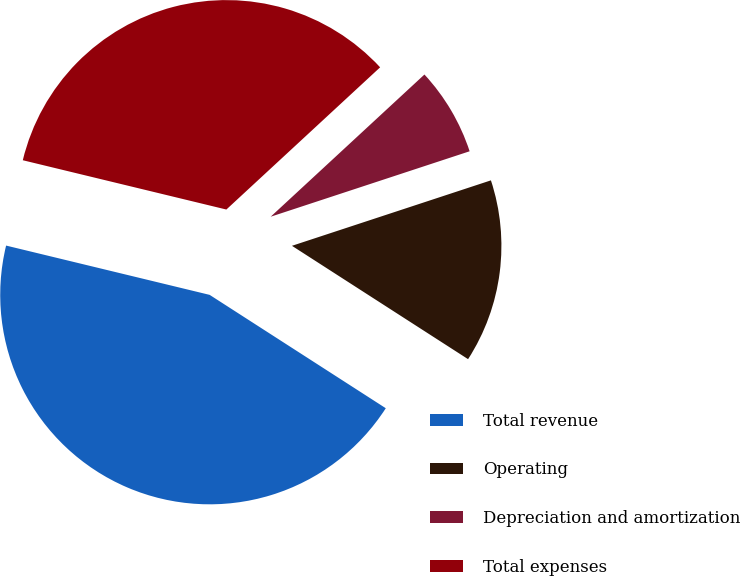Convert chart to OTSL. <chart><loc_0><loc_0><loc_500><loc_500><pie_chart><fcel>Total revenue<fcel>Operating<fcel>Depreciation and amortization<fcel>Total expenses<nl><fcel>44.68%<fcel>14.16%<fcel>6.82%<fcel>34.34%<nl></chart> 